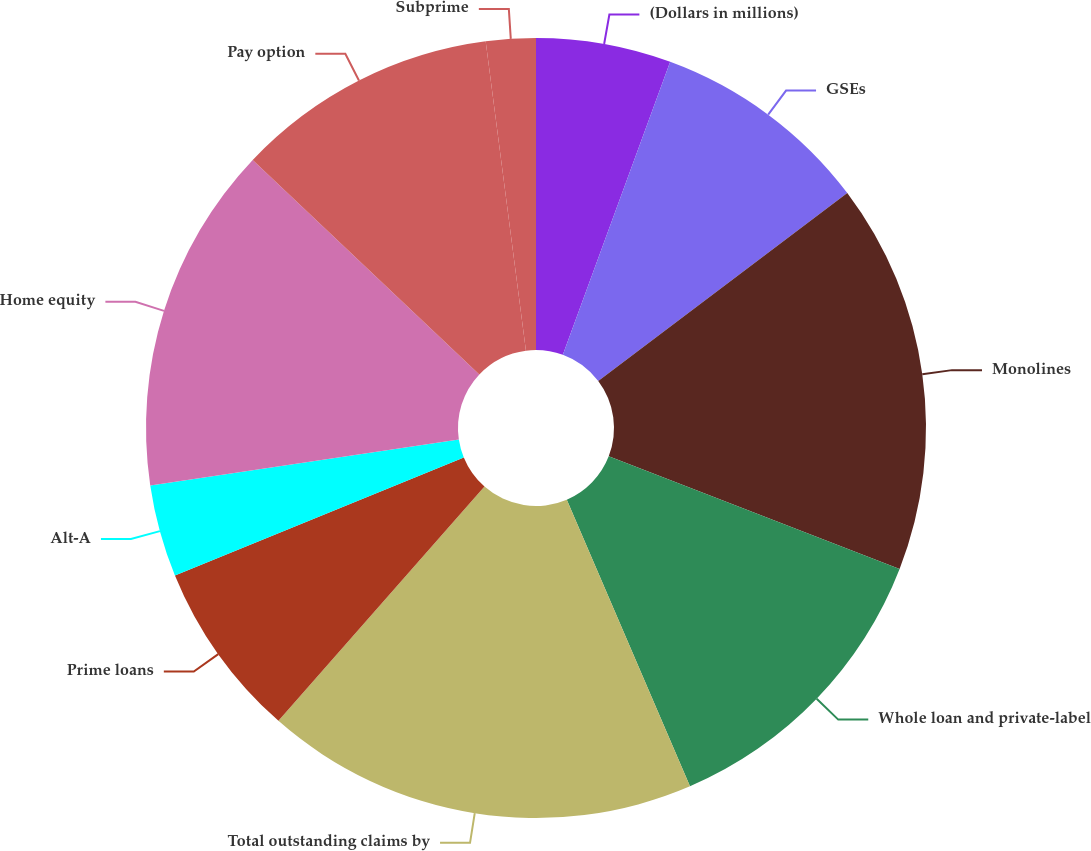Convert chart to OTSL. <chart><loc_0><loc_0><loc_500><loc_500><pie_chart><fcel>(Dollars in millions)<fcel>GSEs<fcel>Monolines<fcel>Whole loan and private-label<fcel>Total outstanding claims by<fcel>Prime loans<fcel>Alt-A<fcel>Home equity<fcel>Pay option<fcel>Subprime<nl><fcel>5.59%<fcel>9.12%<fcel>16.18%<fcel>12.65%<fcel>17.94%<fcel>7.35%<fcel>3.82%<fcel>14.41%<fcel>10.88%<fcel>2.06%<nl></chart> 